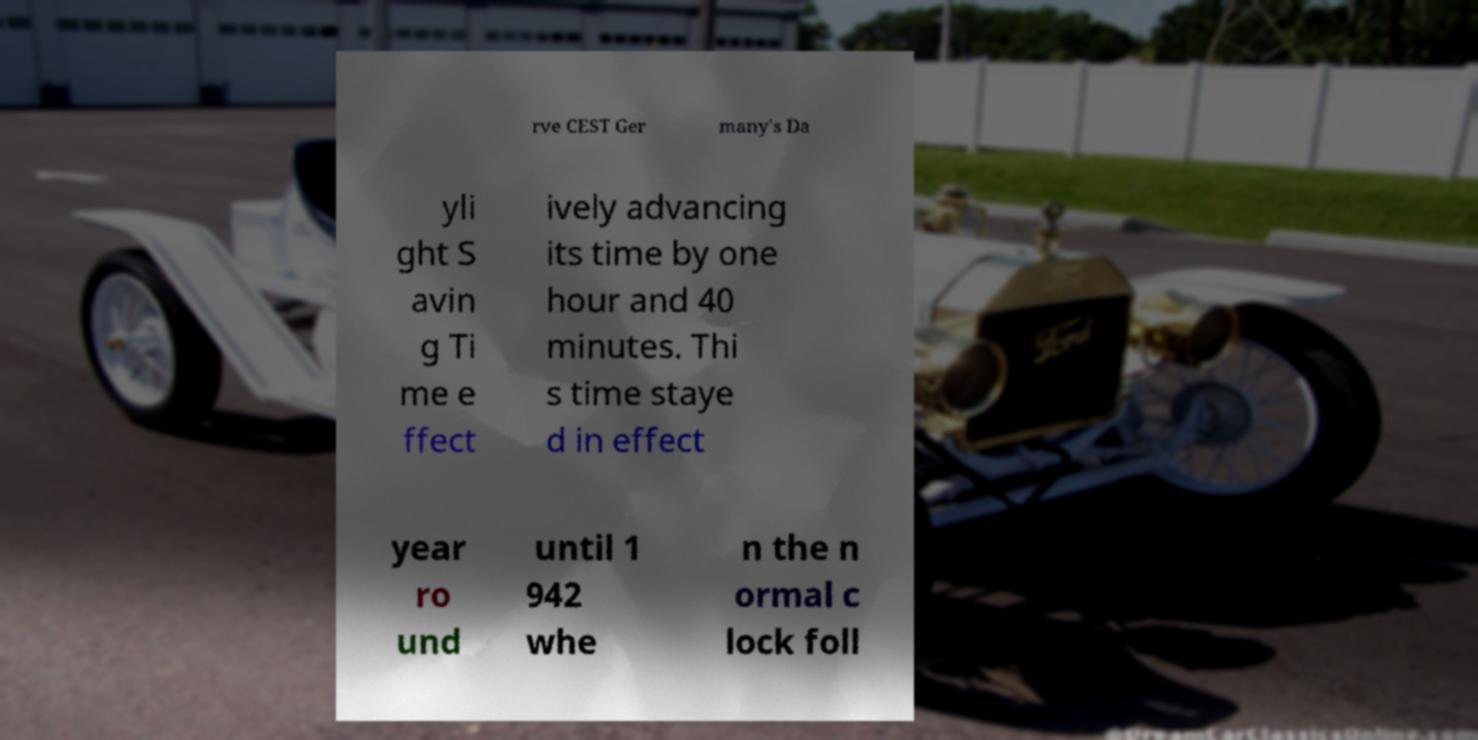Can you read and provide the text displayed in the image?This photo seems to have some interesting text. Can you extract and type it out for me? rve CEST Ger many's Da yli ght S avin g Ti me e ffect ively advancing its time by one hour and 40 minutes. Thi s time staye d in effect year ro und until 1 942 whe n the n ormal c lock foll 